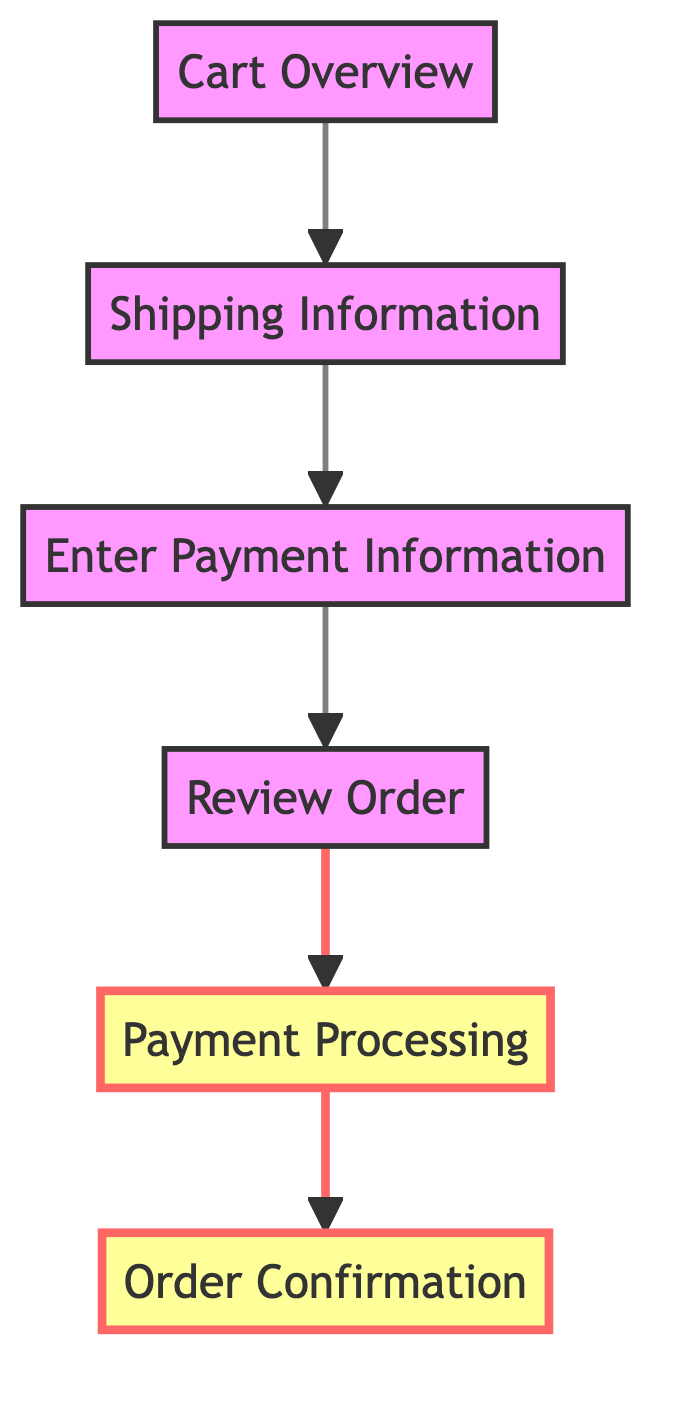What is the first step in the checkout process? The first step in the checkout process, as indicated in the diagram, is "Cart Overview." This is where the user reviews the items in their cart before proceeding.
Answer: Cart Overview How many steps are there in the checkout process? The diagram shows a total of six distinct steps from "Cart Overview" to "Order Confirmation." By counting each node, we confirm that there are six steps.
Answer: 6 What follows after "Enter Payment Information"? According to the flow of the diagram, after "Enter Payment Information," the next step is "Review Order." This shows the sequential nature of the process leading to order verification.
Answer: Review Order Which step highlights the payment processing? The step "Payment Processing" is highlighted in the diagram, indicating its importance in the overall flow. The bold font and color signify that it is a crucial part of the checkout process.
Answer: Payment Processing What is the last step in the checkout process? The final step indicated in the diagram is "Order Confirmation," which concludes the checkout journey with the user receiving confirmation of their order.
Answer: Order Confirmation Which two steps are highlighted in the diagram? The diagram shows "Payment Processing" and "Order Confirmation" as the two highlighted steps, indicating their significance in the finalization of the checkout process.
Answer: Payment Processing, Order Confirmation What is the relationship between "Shipping Information" and "Enter Payment Information"? The relationship is sequential; "Shipping Information" directly leads to "Enter Payment Information," indicating that shipping details must be provided before payment information is entered.
Answer: Sequential relationship How many edges connect the steps in the checkout process? The diagram illustrates five edges that connect the six steps, as each step flows into the next, forming a continuous path from start to end.
Answer: 5 What is the purpose of the "Review Order" step? The "Review Order" step allows the user to verify the selected items, shipping details, and total price before finalizing the payment, ensuring everything is correct prior to processing.
Answer: Verify details 